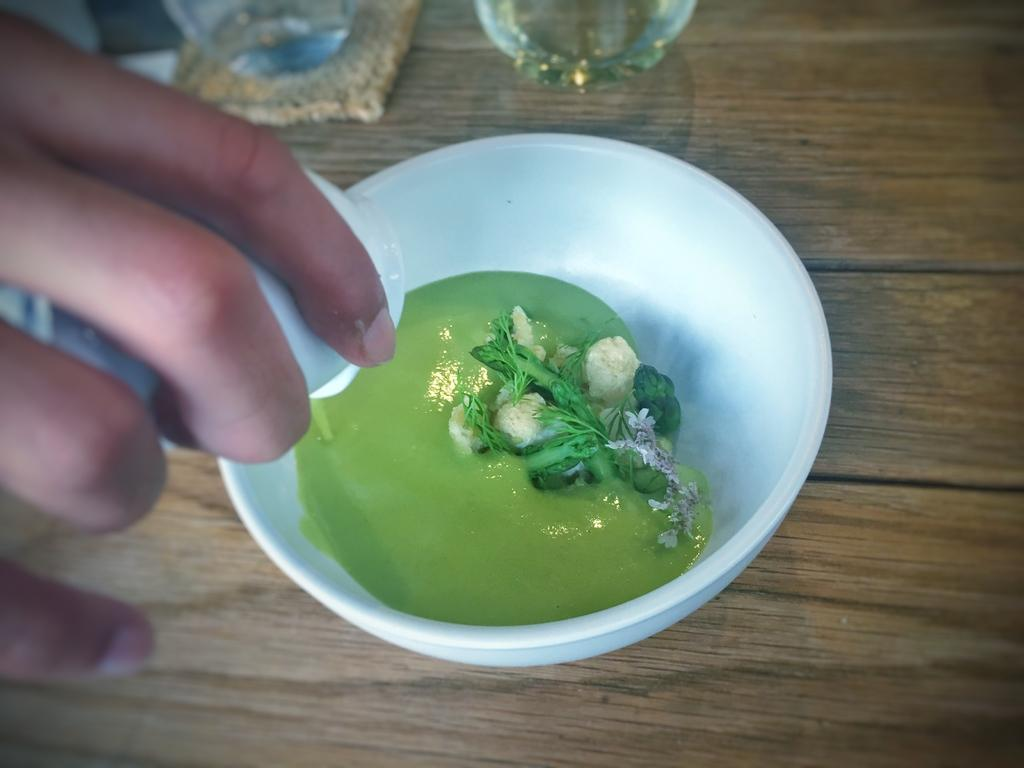What is in the bowl that is visible in the image? There is a food item in a bowl in the image. What is the bowl placed on? The bowl is on a wooden surface. Can you describe anything else visible on the left side of the image? There is a person's hand on the left side of the image. How many giants are present in the image? There are no giants present in the image. What time of day is depicted in the image? The provided facts do not give any information about the time of day, so it cannot be determined from the image. 